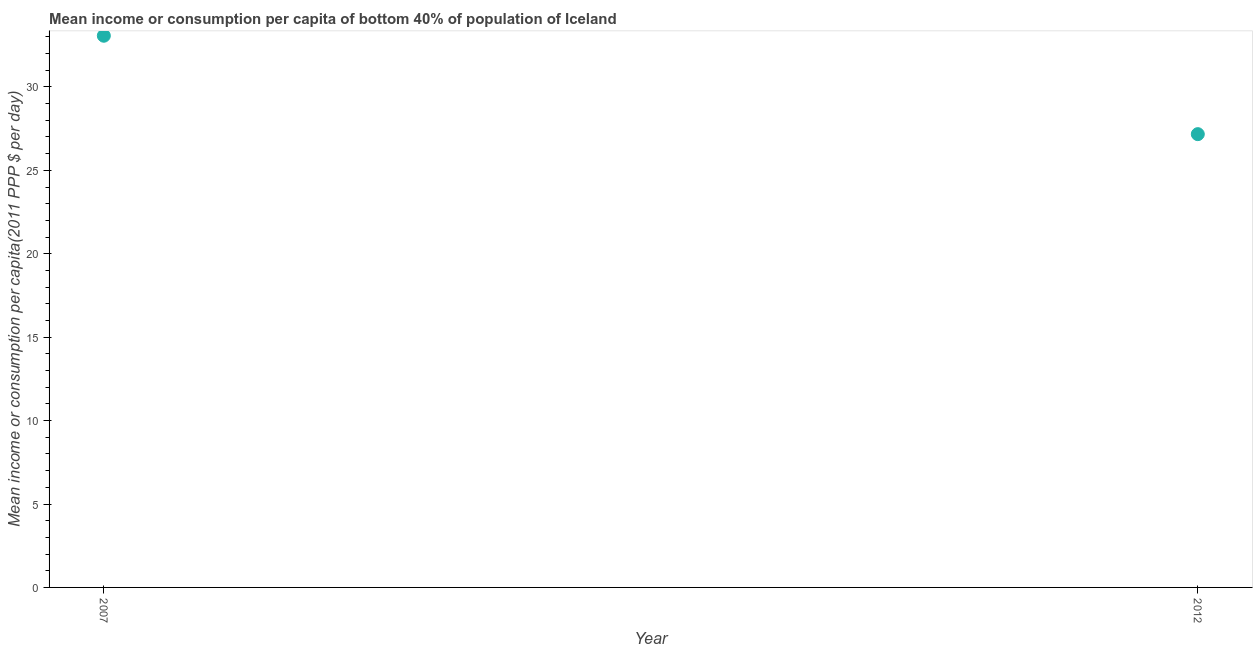What is the mean income or consumption in 2012?
Your answer should be compact. 27.17. Across all years, what is the maximum mean income or consumption?
Provide a short and direct response. 33.07. Across all years, what is the minimum mean income or consumption?
Provide a short and direct response. 27.17. In which year was the mean income or consumption maximum?
Give a very brief answer. 2007. In which year was the mean income or consumption minimum?
Ensure brevity in your answer.  2012. What is the sum of the mean income or consumption?
Ensure brevity in your answer.  60.24. What is the difference between the mean income or consumption in 2007 and 2012?
Make the answer very short. 5.9. What is the average mean income or consumption per year?
Provide a succinct answer. 30.12. What is the median mean income or consumption?
Make the answer very short. 30.12. In how many years, is the mean income or consumption greater than 4 $?
Ensure brevity in your answer.  2. What is the ratio of the mean income or consumption in 2007 to that in 2012?
Provide a succinct answer. 1.22. Is the mean income or consumption in 2007 less than that in 2012?
Give a very brief answer. No. How many dotlines are there?
Your answer should be compact. 1. How many years are there in the graph?
Provide a succinct answer. 2. Does the graph contain any zero values?
Make the answer very short. No. Does the graph contain grids?
Provide a succinct answer. No. What is the title of the graph?
Give a very brief answer. Mean income or consumption per capita of bottom 40% of population of Iceland. What is the label or title of the X-axis?
Make the answer very short. Year. What is the label or title of the Y-axis?
Your answer should be very brief. Mean income or consumption per capita(2011 PPP $ per day). What is the Mean income or consumption per capita(2011 PPP $ per day) in 2007?
Your answer should be compact. 33.07. What is the Mean income or consumption per capita(2011 PPP $ per day) in 2012?
Keep it short and to the point. 27.17. What is the difference between the Mean income or consumption per capita(2011 PPP $ per day) in 2007 and 2012?
Make the answer very short. 5.9. What is the ratio of the Mean income or consumption per capita(2011 PPP $ per day) in 2007 to that in 2012?
Your answer should be compact. 1.22. 